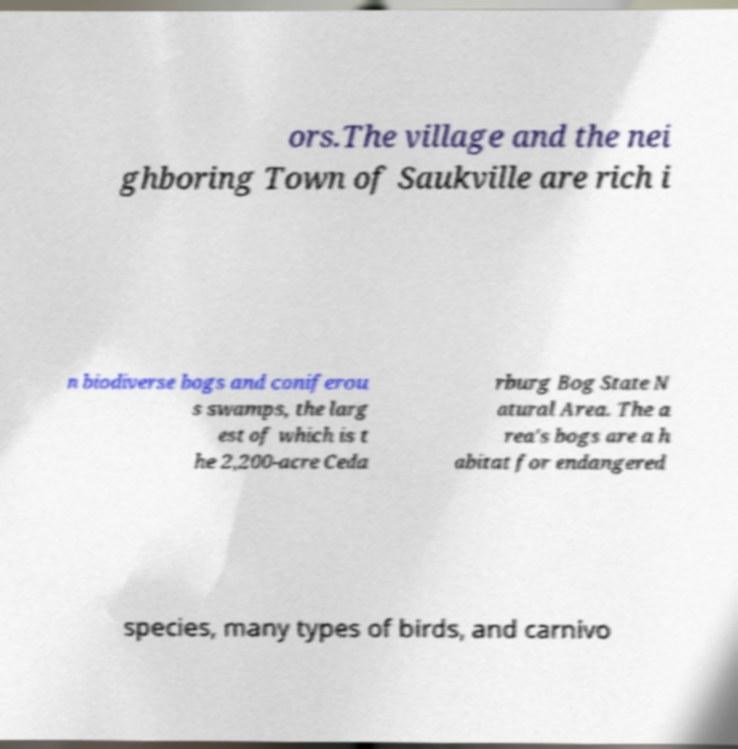For documentation purposes, I need the text within this image transcribed. Could you provide that? ors.The village and the nei ghboring Town of Saukville are rich i n biodiverse bogs and coniferou s swamps, the larg est of which is t he 2,200-acre Ceda rburg Bog State N atural Area. The a rea's bogs are a h abitat for endangered species, many types of birds, and carnivo 